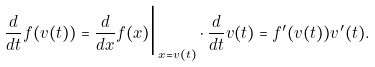<formula> <loc_0><loc_0><loc_500><loc_500>\frac { d } { d t } f ( v ( t ) ) = \frac { d } { d x } f ( x ) \Big | _ { x = v ( t ) } \cdot \frac { d } { d t } v ( t ) = f ^ { \prime } ( v ( t ) ) v ^ { \prime } ( t ) .</formula> 